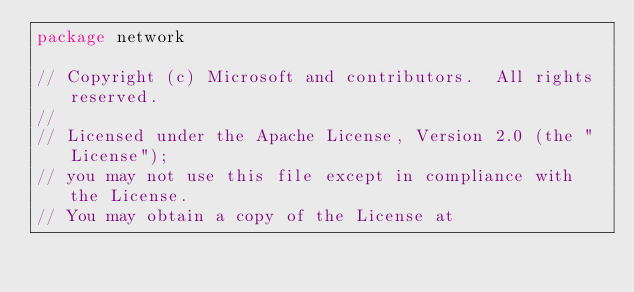Convert code to text. <code><loc_0><loc_0><loc_500><loc_500><_Go_>package network

// Copyright (c) Microsoft and contributors.  All rights reserved.
//
// Licensed under the Apache License, Version 2.0 (the "License");
// you may not use this file except in compliance with the License.
// You may obtain a copy of the License at</code> 